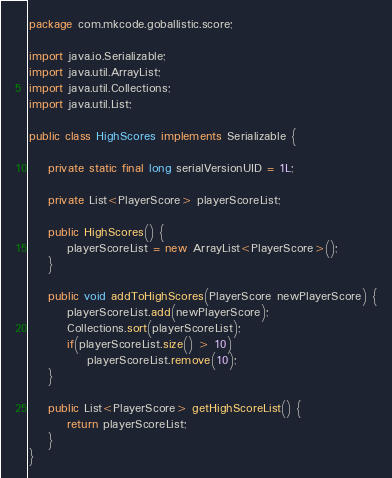Convert code to text. <code><loc_0><loc_0><loc_500><loc_500><_Java_>package com.mkcode.goballistic.score;

import java.io.Serializable;
import java.util.ArrayList;
import java.util.Collections;
import java.util.List;

public class HighScores implements Serializable {

	private static final long serialVersionUID = 1L;
	
	private List<PlayerScore> playerScoreList;
	
	public HighScores() {
		playerScoreList = new ArrayList<PlayerScore>();
	}

	public void addToHighScores(PlayerScore newPlayerScore) {
		playerScoreList.add(newPlayerScore);
		Collections.sort(playerScoreList);
		if(playerScoreList.size() > 10)
			playerScoreList.remove(10);
	}
	
	public List<PlayerScore> getHighScoreList() {
		return playerScoreList;
	}
}
</code> 